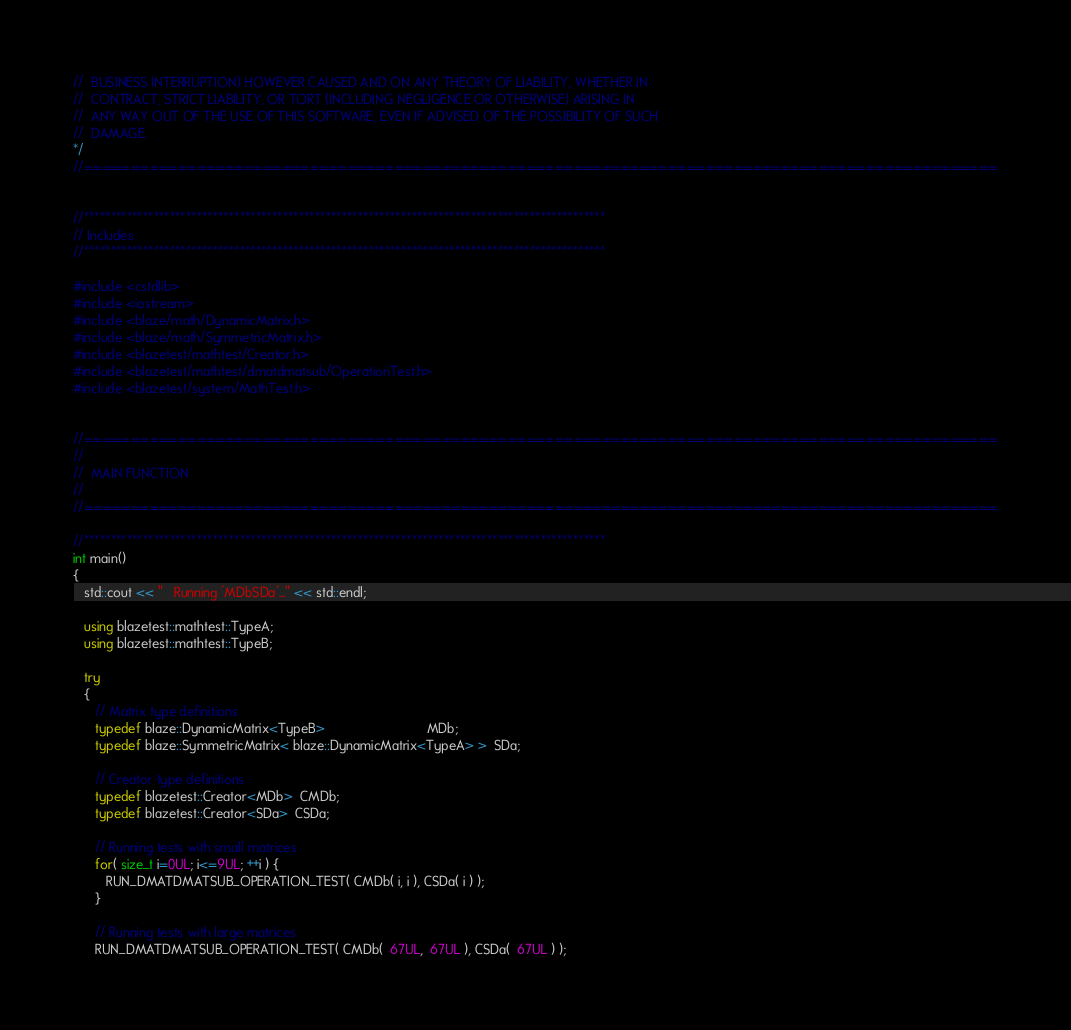<code> <loc_0><loc_0><loc_500><loc_500><_C++_>//  BUSINESS INTERRUPTION) HOWEVER CAUSED AND ON ANY THEORY OF LIABILITY, WHETHER IN
//  CONTRACT, STRICT LIABILITY, OR TORT (INCLUDING NEGLIGENCE OR OTHERWISE) ARISING IN
//  ANY WAY OUT OF THE USE OF THIS SOFTWARE, EVEN IF ADVISED OF THE POSSIBILITY OF SUCH
//  DAMAGE.
*/
//=================================================================================================


//*************************************************************************************************
// Includes
//*************************************************************************************************

#include <cstdlib>
#include <iostream>
#include <blaze/math/DynamicMatrix.h>
#include <blaze/math/SymmetricMatrix.h>
#include <blazetest/mathtest/Creator.h>
#include <blazetest/mathtest/dmatdmatsub/OperationTest.h>
#include <blazetest/system/MathTest.h>


//=================================================================================================
//
//  MAIN FUNCTION
//
//=================================================================================================

//*************************************************************************************************
int main()
{
   std::cout << "   Running 'MDbSDa'..." << std::endl;

   using blazetest::mathtest::TypeA;
   using blazetest::mathtest::TypeB;

   try
   {
      // Matrix type definitions
      typedef blaze::DynamicMatrix<TypeB>                            MDb;
      typedef blaze::SymmetricMatrix< blaze::DynamicMatrix<TypeA> >  SDa;

      // Creator type definitions
      typedef blazetest::Creator<MDb>  CMDb;
      typedef blazetest::Creator<SDa>  CSDa;

      // Running tests with small matrices
      for( size_t i=0UL; i<=9UL; ++i ) {
         RUN_DMATDMATSUB_OPERATION_TEST( CMDb( i, i ), CSDa( i ) );
      }

      // Running tests with large matrices
      RUN_DMATDMATSUB_OPERATION_TEST( CMDb(  67UL,  67UL ), CSDa(  67UL ) );</code> 